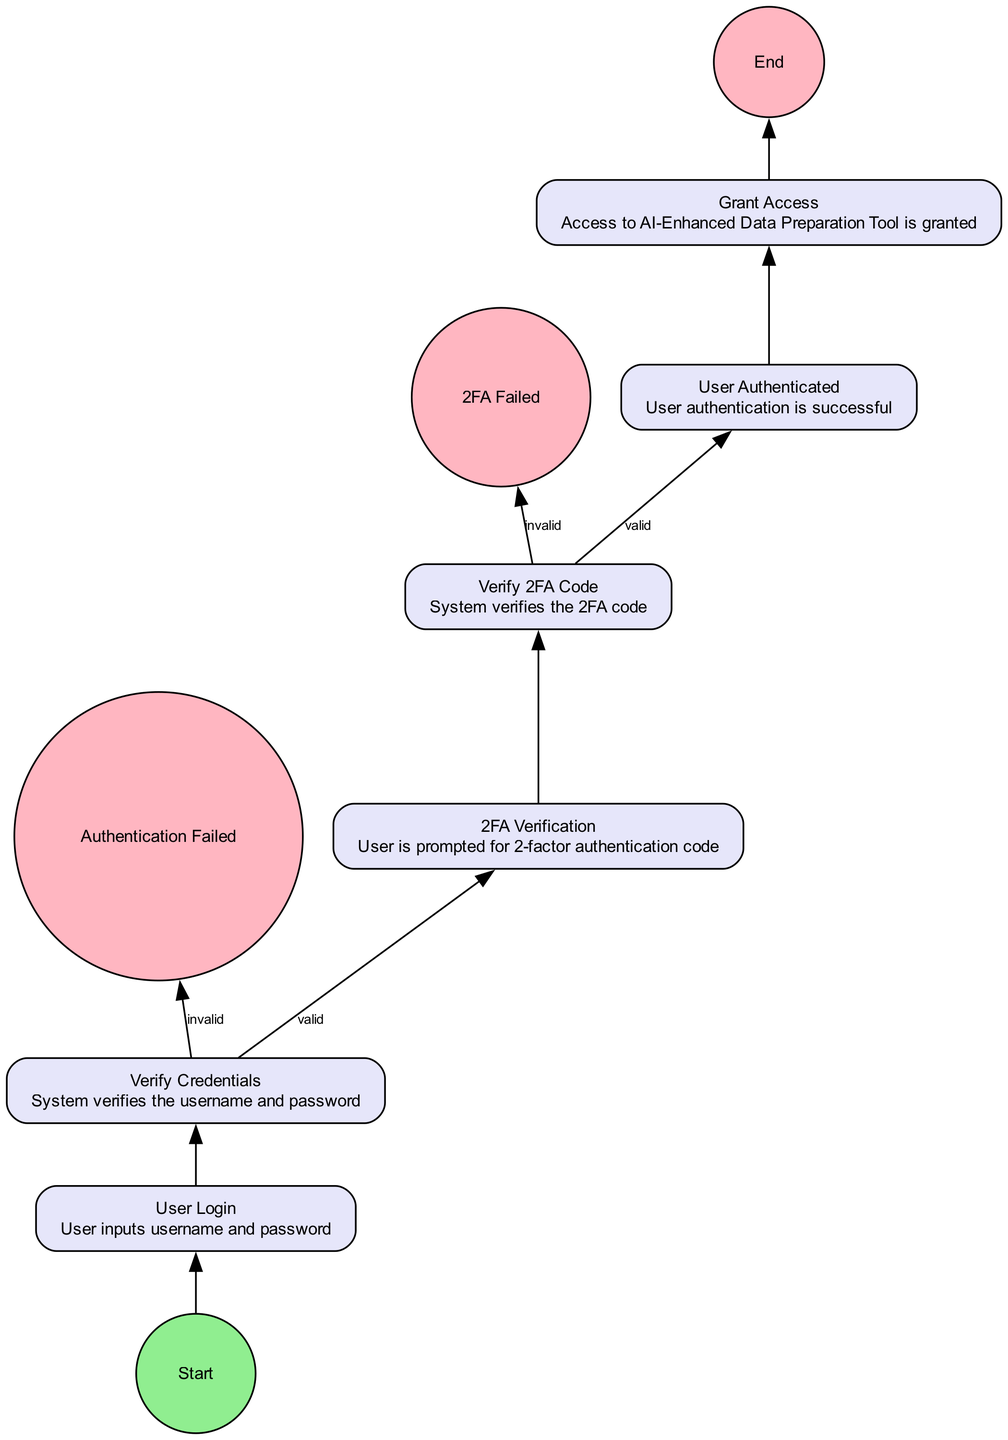What is the first step in the authentication flow? The first step is the "Start" node, indicating where the flow begins. Following the "Start" node, the next step is "User Login."
Answer: Start How many processes are involved in the user authentication flow? The diagram lists six process nodes, namely "User Login," "Verify Credentials," "2FA Verification," "Verify 2FA Code," "User Authenticated," and "Grant Access."
Answer: Six What happens if the credentials are invalid? If the credentials are invalid, the flow leads to the "Authentication Failed" end event, terminating the authentication process.
Answer: Authentication Failed What step follows the verification of the 2FA code if it's valid? If the 2FA code is verified successfully, the next step is "User Authenticated," indicating that the user has passed all authentication checks.
Answer: User Authenticated What is the condition for proceeding from "Verify Credentials" to "2FA Verification"? The condition for proceeding from "Verify Credentials" to "2FA Verification" is that the credentials must be valid.
Answer: Valid If a user fails the 2FA verification, where does the flow end? If a user fails the 2FA verification, the flow ends at the "2FA Failed" end event, indicating unsuccessful authentication.
Answer: 2FA Failed How many total end events are there in the diagram? The diagram contains two end events: "Authentication Failed" and "2FA Failed." Thus, the total number of end events is two.
Answer: Two Which node grants access to the AI-Enhanced Data Preparation Tool? The node that grants access is "Grant Access," which follows successful user authentication and indicates access permissions.
Answer: Grant Access What verification occurs after user login? After user login, the "Verify Credentials" process occurs to check the validity of the username and password input by the user.
Answer: Verify Credentials 